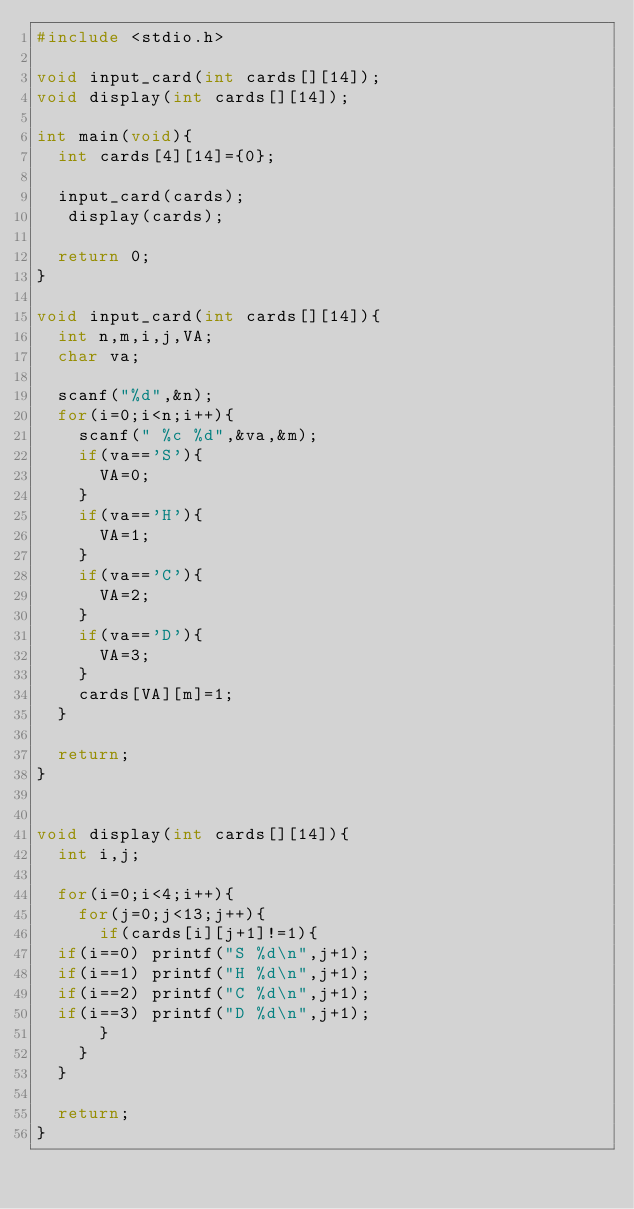<code> <loc_0><loc_0><loc_500><loc_500><_C_>#include <stdio.h>

void input_card(int cards[][14]);
void display(int cards[][14]); 

int main(void){
  int cards[4][14]={0};

  input_card(cards);
   display(cards); 

  return 0;
}

void input_card(int cards[][14]){
  int n,m,i,j,VA;
  char va;

  scanf("%d",&n);
  for(i=0;i<n;i++){
    scanf(" %c %d",&va,&m);
    if(va=='S'){
      VA=0;
    }
    if(va=='H'){
      VA=1;
    }
    if(va=='C'){
      VA=2;
    }
    if(va=='D'){
      VA=3;
    }
    cards[VA][m]=1;
  }

  return;
}


void display(int cards[][14]){
  int i,j;

  for(i=0;i<4;i++){
    for(j=0;j<13;j++){
      if(cards[i][j+1]!=1){
	if(i==0) printf("S %d\n",j+1);
	if(i==1) printf("H %d\n",j+1);
	if(i==2) printf("C %d\n",j+1);
	if(i==3) printf("D %d\n",j+1);
      }
    }
  }

  return;
}</code> 